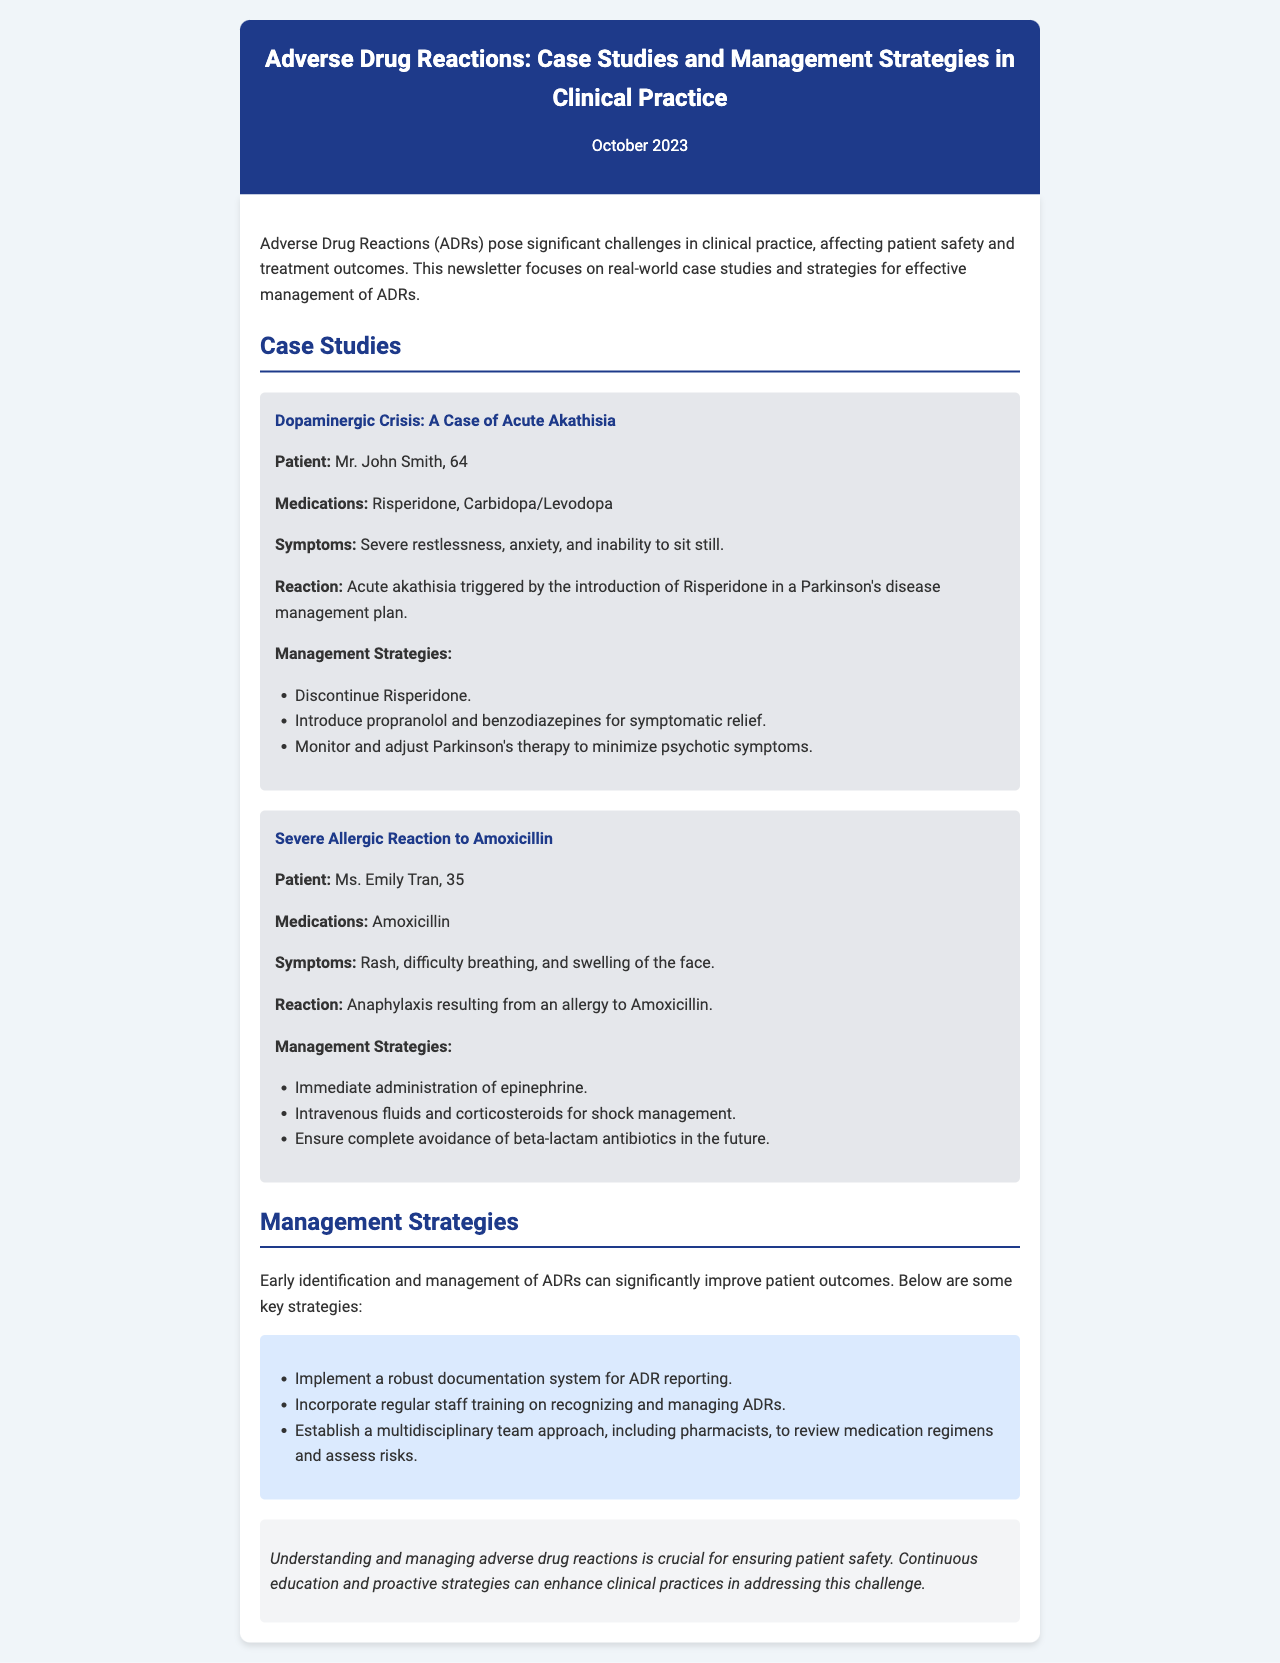what is the title of the newsletter? The title of the newsletter is prominently displayed at the top of the document.
Answer: Adverse Drug Reactions: Case Studies and Management Strategies in Clinical Practice who is the patient in the case of acute akathisia? The patient’s name is mentioned in the case study about acute akathisia.
Answer: Mr. John Smith what medication resulted in the allergic reaction in Ms. Emily Tran? The medication that caused the allergic reaction is specifically stated in the case study.
Answer: Amoxicillin which medication was introduced that led to acute akathisia? The document details the reaction triggered by the introduction of a specific medication.
Answer: Risperidone what immediate treatment was administered for the allergic reaction? The newsletter provides the initial treatment for the allergic reaction clearly.
Answer: epinephrine how many patients are discussed in the case studies? The document lists the case studies and the number of patients involved.
Answer: 2 what is one key strategy for managing ADRs mentioned in the newsletter? The management strategies section outlines several methods for effective ADR management.
Answer: document system for ADR reporting what type of document is this? The structure and presentation of the information indicate the type of document.
Answer: newsletter 